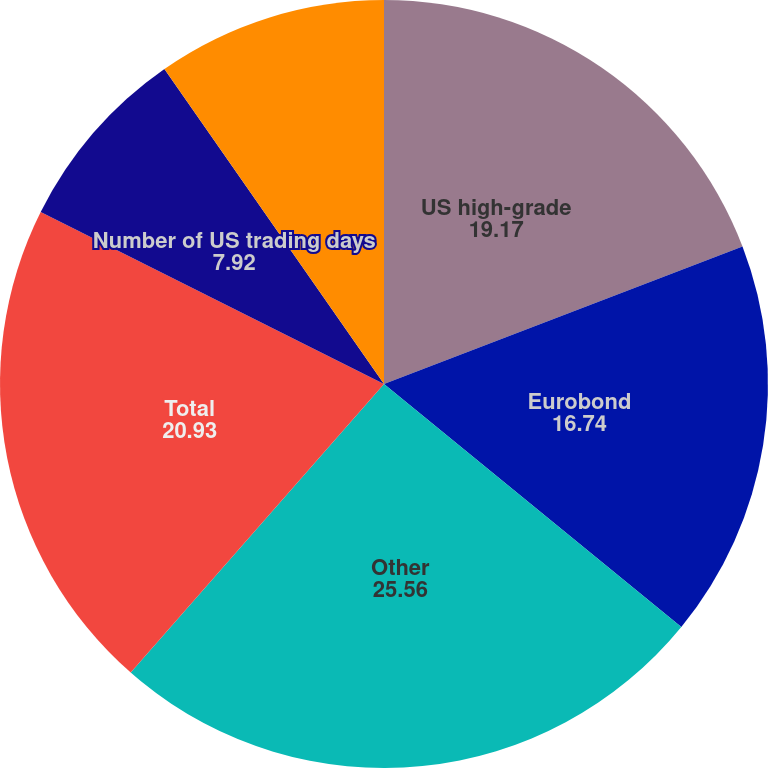<chart> <loc_0><loc_0><loc_500><loc_500><pie_chart><fcel>US high-grade<fcel>Eurobond<fcel>Other<fcel>Total<fcel>Number of US trading days<fcel>Number of UK trading days<nl><fcel>19.17%<fcel>16.74%<fcel>25.56%<fcel>20.93%<fcel>7.92%<fcel>9.69%<nl></chart> 